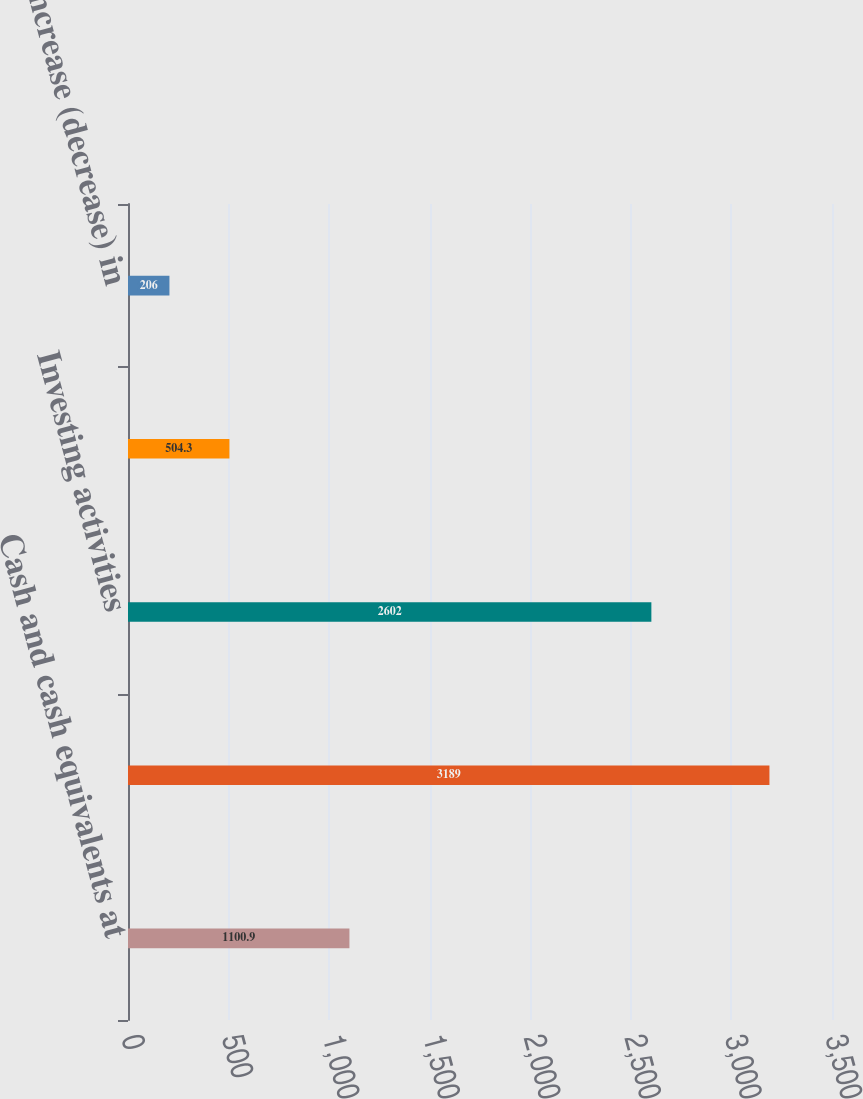<chart> <loc_0><loc_0><loc_500><loc_500><bar_chart><fcel>Cash and cash equivalents at<fcel>Operating activities<fcel>Investing activities<fcel>Financing activities<fcel>Net increase (decrease) in<nl><fcel>1100.9<fcel>3189<fcel>2602<fcel>504.3<fcel>206<nl></chart> 